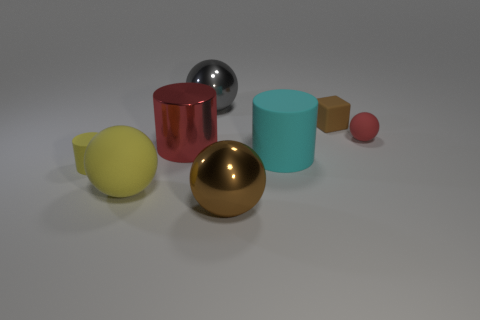Add 2 green matte cylinders. How many objects exist? 10 Subtract all blocks. How many objects are left? 7 Subtract all small matte blocks. Subtract all red rubber things. How many objects are left? 6 Add 3 matte objects. How many matte objects are left? 8 Add 8 yellow objects. How many yellow objects exist? 10 Subtract 0 blue balls. How many objects are left? 8 